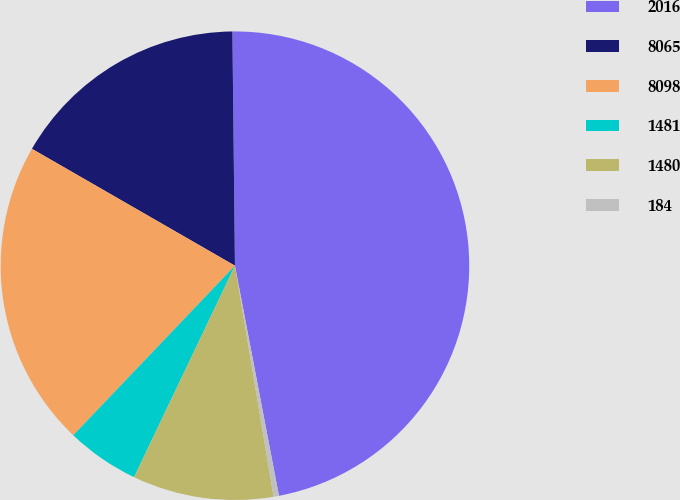Convert chart. <chart><loc_0><loc_0><loc_500><loc_500><pie_chart><fcel>2016<fcel>8065<fcel>8098<fcel>1481<fcel>1480<fcel>184<nl><fcel>47.16%<fcel>16.51%<fcel>21.19%<fcel>5.04%<fcel>9.72%<fcel>0.37%<nl></chart> 